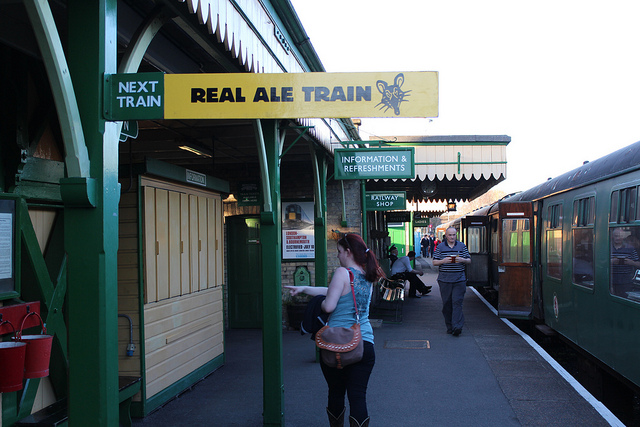<image>What platform number is this? It is unknown what the platform number is. It can be 2, 0, 1, 10, 4, or 12. What platform number is this? I don't know what platform number this is. It can be seen as '2', '1', '4', '12', '0', or '10'. 